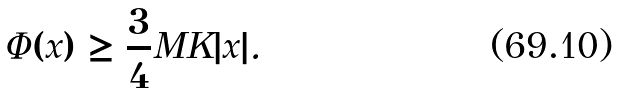<formula> <loc_0><loc_0><loc_500><loc_500>\Phi ( x ) \geq \frac { 3 } { 4 } M K | x | .</formula> 